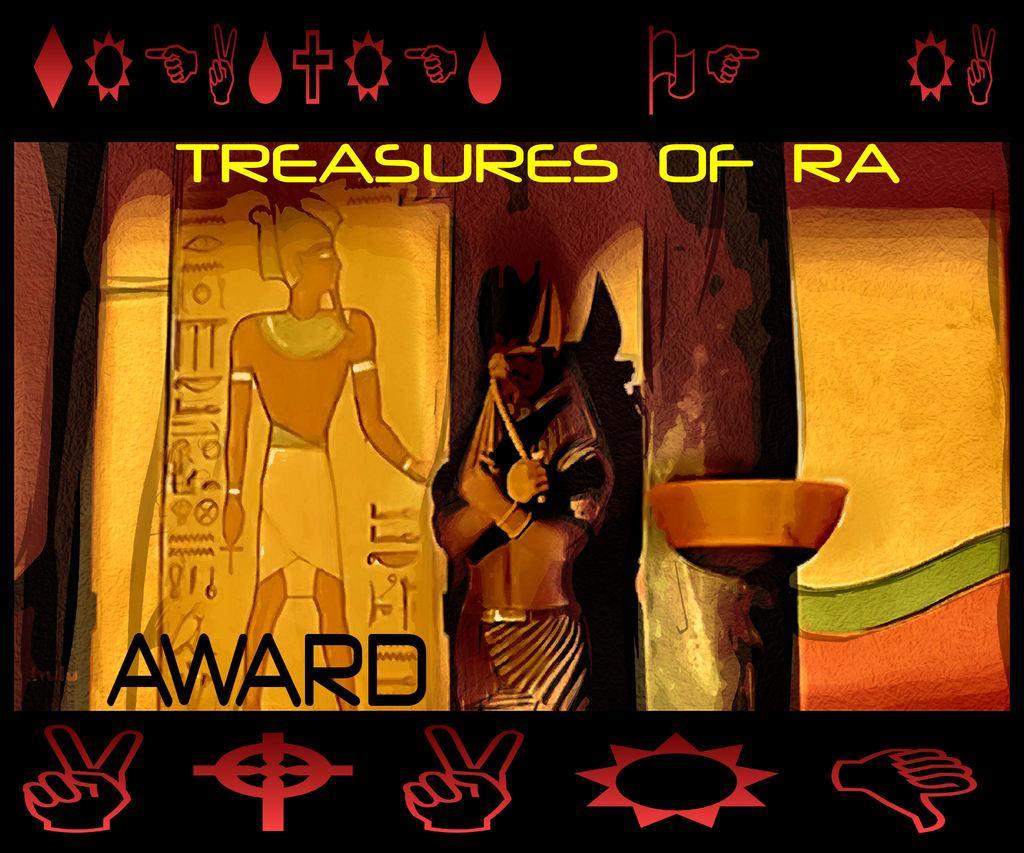In one or two sentences, can you explain what this image depicts? It is an animated image. There is a statue and logos. Something is written on the animated picture.  